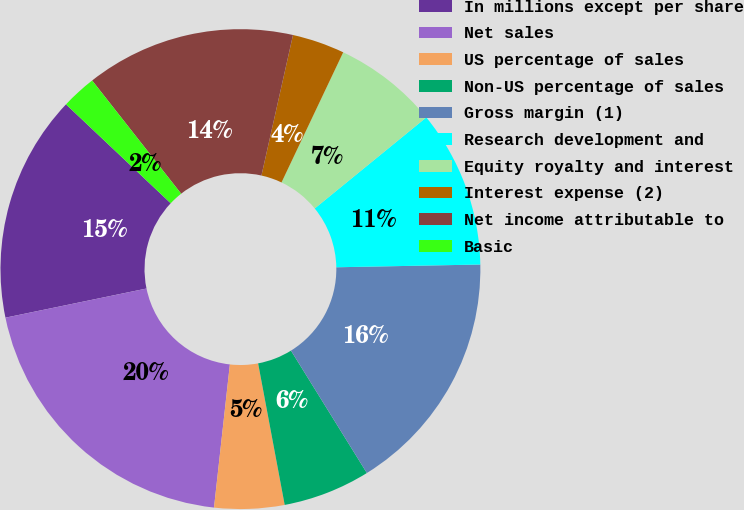<chart> <loc_0><loc_0><loc_500><loc_500><pie_chart><fcel>In millions except per share<fcel>Net sales<fcel>US percentage of sales<fcel>Non-US percentage of sales<fcel>Gross margin (1)<fcel>Research development and<fcel>Equity royalty and interest<fcel>Interest expense (2)<fcel>Net income attributable to<fcel>Basic<nl><fcel>15.29%<fcel>20.0%<fcel>4.71%<fcel>5.88%<fcel>16.47%<fcel>10.59%<fcel>7.06%<fcel>3.53%<fcel>14.12%<fcel>2.35%<nl></chart> 